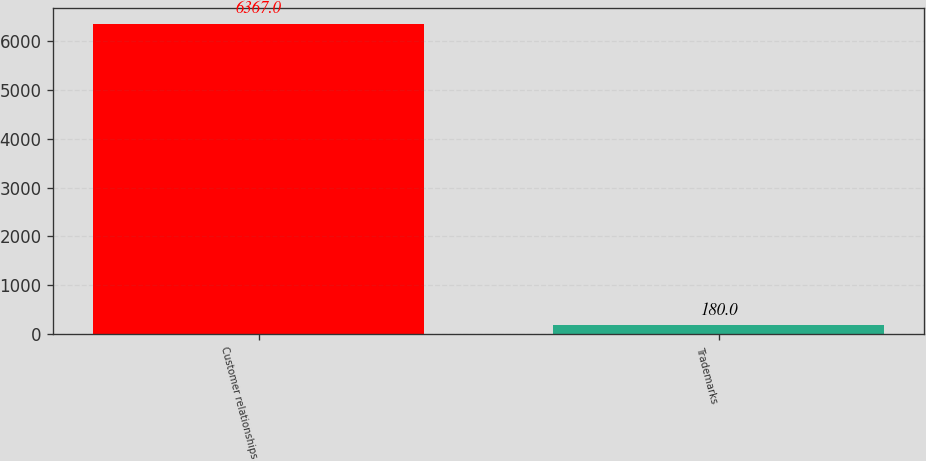Convert chart to OTSL. <chart><loc_0><loc_0><loc_500><loc_500><bar_chart><fcel>Customer relationships<fcel>Trademarks<nl><fcel>6367<fcel>180<nl></chart> 